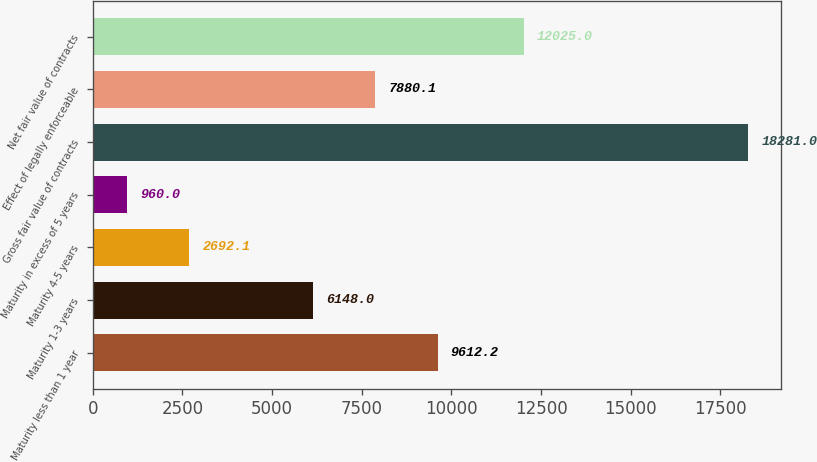<chart> <loc_0><loc_0><loc_500><loc_500><bar_chart><fcel>Maturity less than 1 year<fcel>Maturity 1-3 years<fcel>Maturity 4-5 years<fcel>Maturity in excess of 5 years<fcel>Gross fair value of contracts<fcel>Effect of legally enforceable<fcel>Net fair value of contracts<nl><fcel>9612.2<fcel>6148<fcel>2692.1<fcel>960<fcel>18281<fcel>7880.1<fcel>12025<nl></chart> 